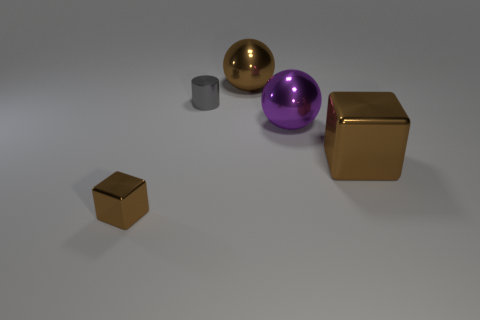Add 5 big brown balls. How many objects exist? 10 Subtract all brown balls. Subtract all cyan cylinders. How many balls are left? 1 Subtract all blocks. How many objects are left? 3 Subtract 0 yellow cylinders. How many objects are left? 5 Subtract all small blue matte blocks. Subtract all tiny gray metallic cylinders. How many objects are left? 4 Add 3 large spheres. How many large spheres are left? 5 Add 1 gray metal cylinders. How many gray metal cylinders exist? 2 